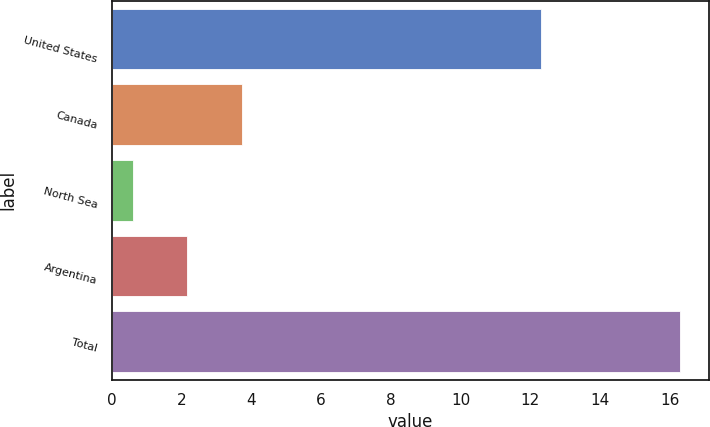<chart> <loc_0><loc_0><loc_500><loc_500><bar_chart><fcel>United States<fcel>Canada<fcel>North Sea<fcel>Argentina<fcel>Total<nl><fcel>12.3<fcel>3.74<fcel>0.6<fcel>2.17<fcel>16.3<nl></chart> 